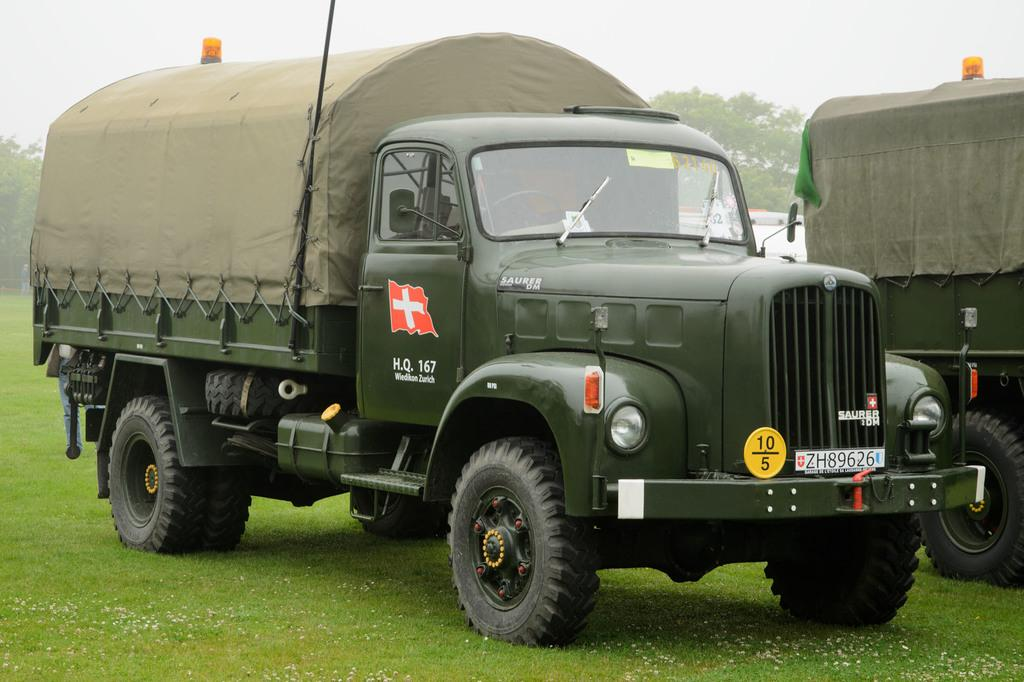What is the main subject in the center of the image? There is a van in the center of the image. Are there any other vans visible in the image? Yes, there is a van on the right side of the image. Where are the vans located? Both vans are on the grass. What can be seen in the background of the image? There is grass, trees, and the sky visible in the background of the image. What is the condition of the sky in the image? Clouds are present in the sky. What type of underwear is hanging from the trees in the image? There is no underwear present in the image; it only features vans on the grass and trees in the background. 